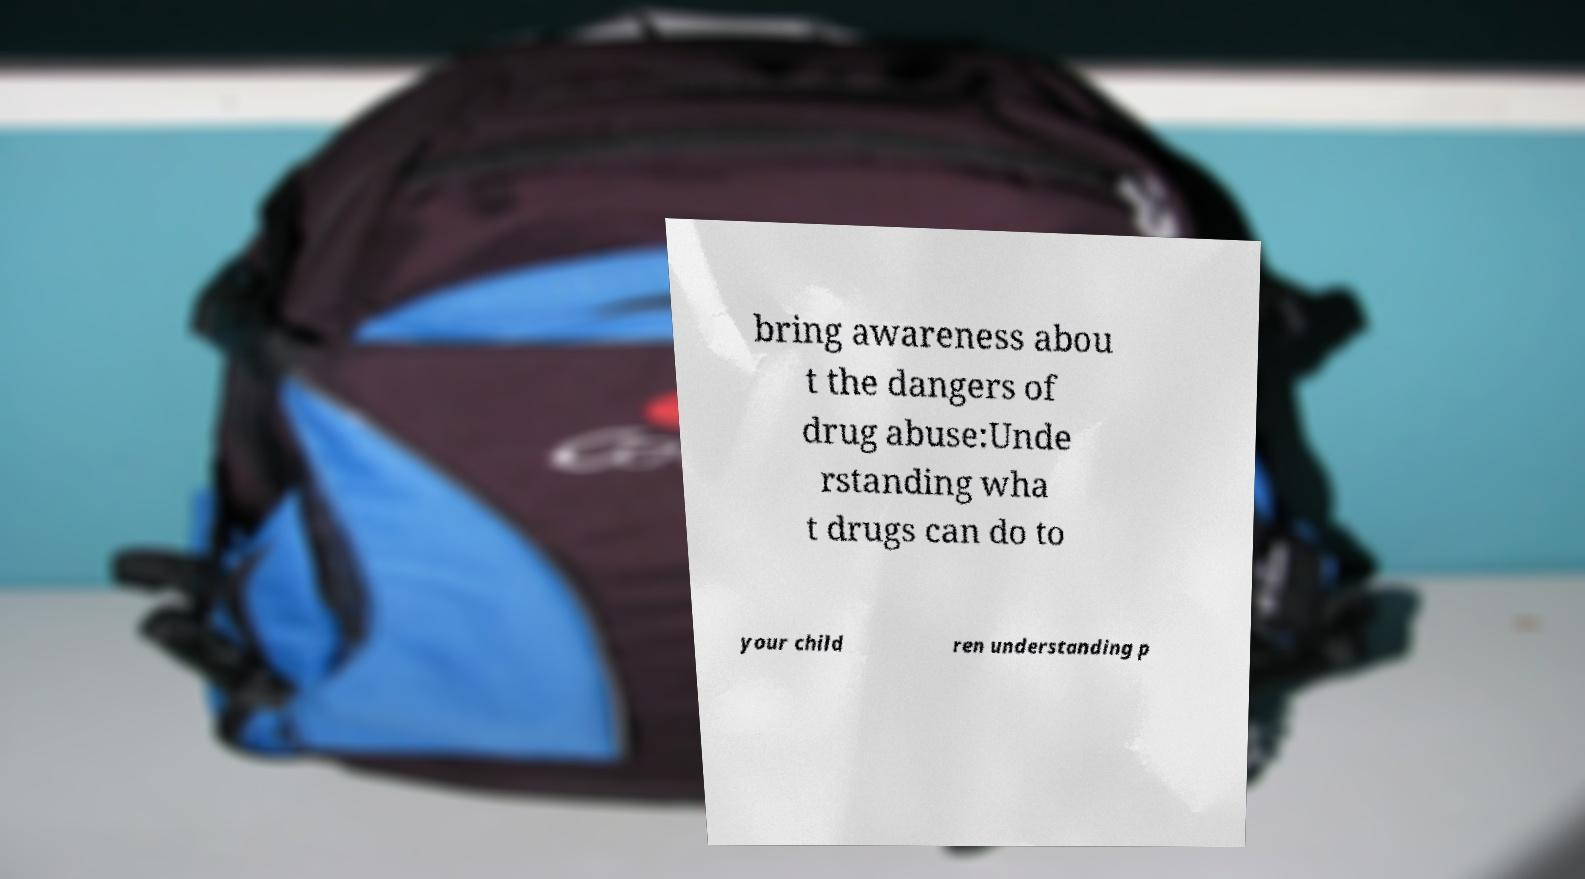Please identify and transcribe the text found in this image. bring awareness abou t the dangers of drug abuse:Unde rstanding wha t drugs can do to your child ren understanding p 